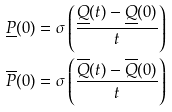<formula> <loc_0><loc_0><loc_500><loc_500>\underline { P } ( 0 ) & = \sigma \left ( \frac { \underline { Q } ( t ) - \underline { Q } ( 0 ) } { t } \right ) \\ \overline { P } ( 0 ) & = \sigma \left ( \frac { \overline { Q } ( t ) - \overline { Q } ( 0 ) } { t } \right )</formula> 